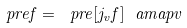<formula> <loc_0><loc_0><loc_500><loc_500>\ p r e { f } = \ p r e { [ j _ { v } f ] } \ a m a p { v }</formula> 